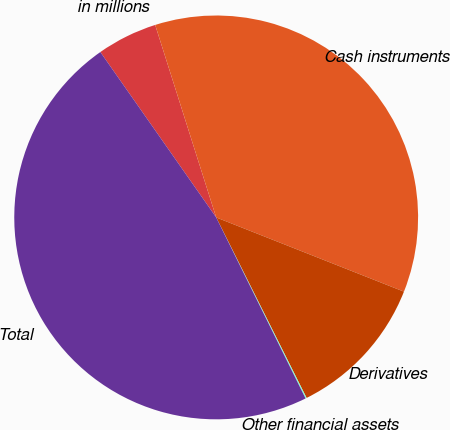<chart> <loc_0><loc_0><loc_500><loc_500><pie_chart><fcel>in millions<fcel>Cash instruments<fcel>Derivatives<fcel>Other financial assets<fcel>Total<nl><fcel>4.84%<fcel>35.88%<fcel>11.62%<fcel>0.09%<fcel>47.58%<nl></chart> 